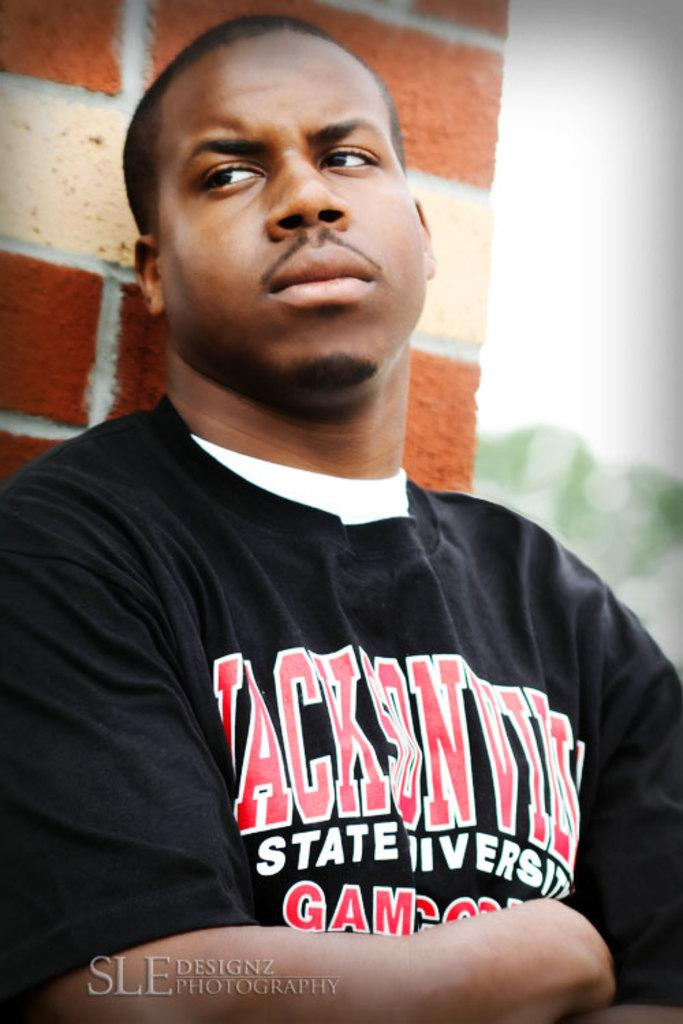<image>
Create a compact narrative representing the image presented. A photograph by SLE Designz Photography of a man wearing a Jacksonville State University shirt. 